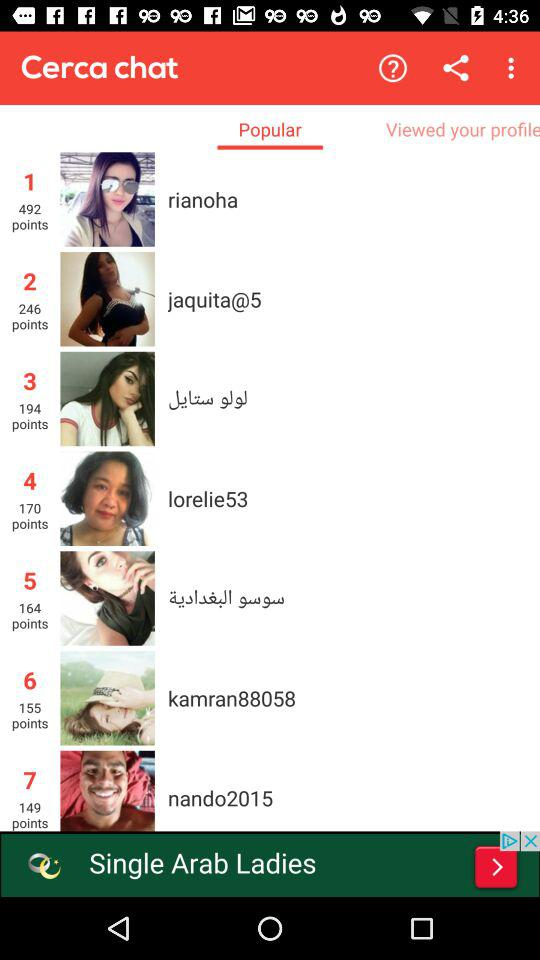How many points does the user "jaquita@5" have? The user "jaquita@5" has 246 points. 